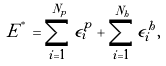<formula> <loc_0><loc_0><loc_500><loc_500>E ^ { ^ { * } } = \sum _ { i = 1 } ^ { N _ { p } } \epsilon ^ { p } _ { i } + \sum _ { i = 1 } ^ { N _ { h } } \epsilon ^ { h } _ { i } ,</formula> 